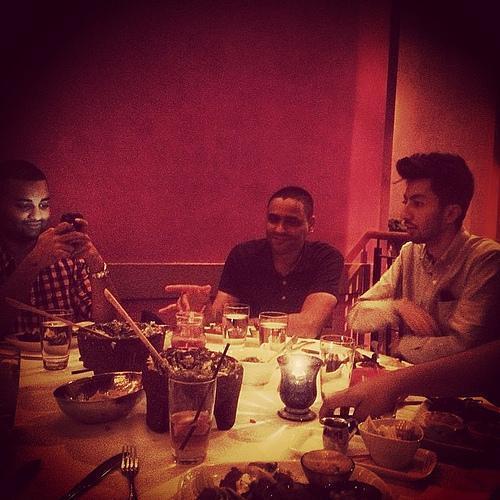How many people are clearly shown in this picture?
Give a very brief answer. 3. How many pots of food are on the table?
Give a very brief answer. 2. 